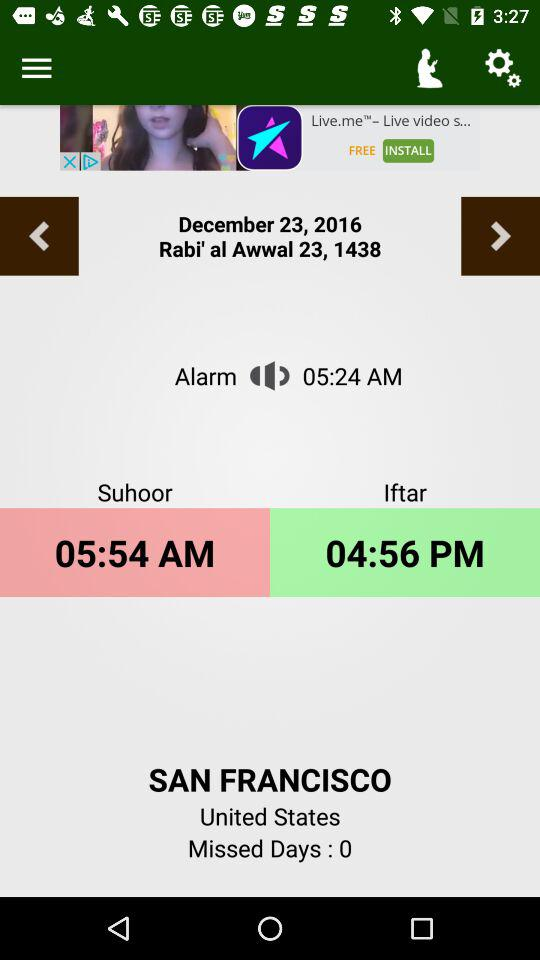What time does the alarm go off?
When the provided information is insufficient, respond with <no answer>. <no answer> 